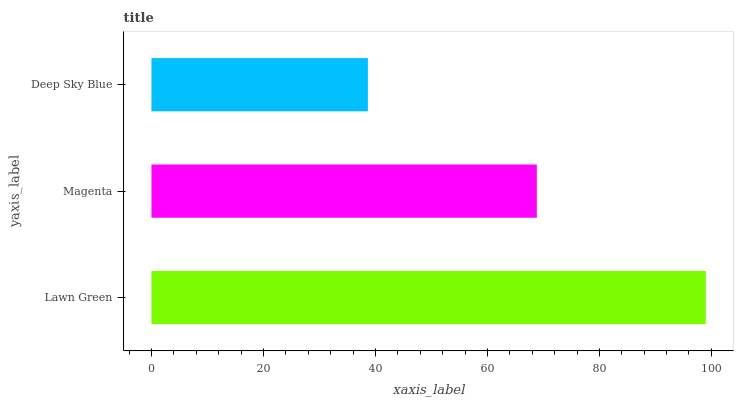Is Deep Sky Blue the minimum?
Answer yes or no. Yes. Is Lawn Green the maximum?
Answer yes or no. Yes. Is Magenta the minimum?
Answer yes or no. No. Is Magenta the maximum?
Answer yes or no. No. Is Lawn Green greater than Magenta?
Answer yes or no. Yes. Is Magenta less than Lawn Green?
Answer yes or no. Yes. Is Magenta greater than Lawn Green?
Answer yes or no. No. Is Lawn Green less than Magenta?
Answer yes or no. No. Is Magenta the high median?
Answer yes or no. Yes. Is Magenta the low median?
Answer yes or no. Yes. Is Lawn Green the high median?
Answer yes or no. No. Is Deep Sky Blue the low median?
Answer yes or no. No. 